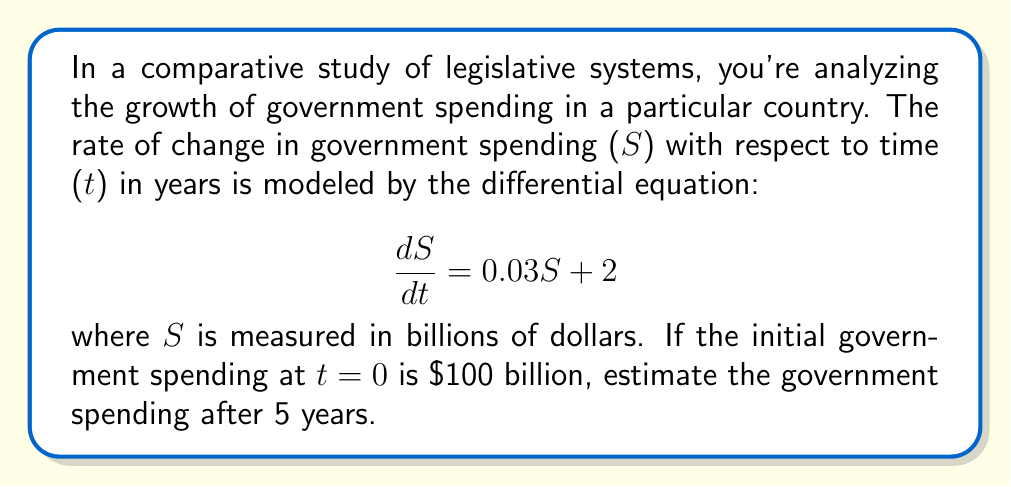Solve this math problem. To solve this problem, we need to follow these steps:

1) First, recognize that this is a first-order linear differential equation in the form:

   $$\frac{dS}{dt} = aS + b$$

   where a = 0.03 and b = 2

2) The general solution for this type of equation is:

   $$S(t) = Ce^{at} - \frac{b}{a}$$

   where C is a constant we need to determine using the initial condition.

3) Substitute the values of a and b:

   $$S(t) = Ce^{0.03t} - \frac{2}{0.03}$$

4) Use the initial condition S(0) = 100 to find C:

   $$100 = Ce^{0.03(0)} - \frac{2}{0.03}$$
   $$100 = C - 66.67$$
   $$C = 166.67$$

5) Now we have the particular solution:

   $$S(t) = 166.67e^{0.03t} - 66.67$$

6) To estimate the government spending after 5 years, we calculate S(5):

   $$S(5) = 166.67e^{0.03(5)} - 66.67$$
   $$S(5) = 166.67e^{0.15} - 66.67$$
   $$S(5) = 166.67(1.1618) - 66.67$$
   $$S(5) = 193.64 - 66.67$$
   $$S(5) = 126.97$$

Therefore, after 5 years, the estimated government spending will be approximately $126.97 billion.
Answer: $126.97 billion 